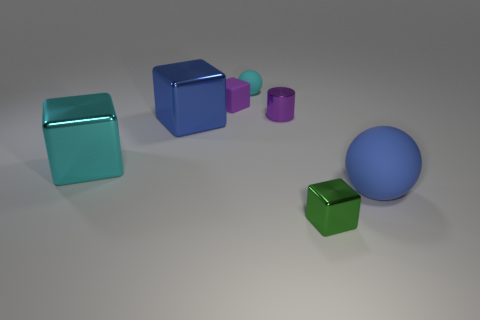What size is the matte object to the right of the purple cylinder?
Your response must be concise. Large. Are there any metal objects of the same color as the tiny cylinder?
Make the answer very short. No. Does the small shiny block have the same color as the small sphere?
Give a very brief answer. No. There is a object that is the same color as the metal cylinder; what is its shape?
Ensure brevity in your answer.  Cube. What number of big blue cubes are in front of the ball that is in front of the small purple block?
Provide a succinct answer. 0. How many blue cubes have the same material as the tiny purple block?
Offer a terse response. 0. Are there any purple metallic cylinders behind the cyan matte ball?
Your answer should be very brief. No. What color is the cylinder that is the same size as the green shiny block?
Ensure brevity in your answer.  Purple. How many things are either big cyan metallic things that are in front of the cyan sphere or tiny purple cylinders?
Your answer should be compact. 2. How big is the object that is both behind the cylinder and on the left side of the tiny sphere?
Your answer should be very brief. Small. 